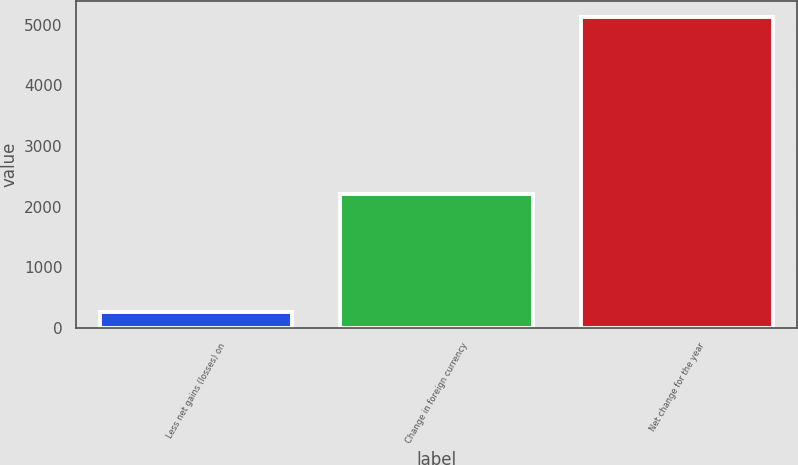Convert chart to OTSL. <chart><loc_0><loc_0><loc_500><loc_500><bar_chart><fcel>Less net gains (losses) on<fcel>Change in foreign currency<fcel>Net change for the year<nl><fcel>265<fcel>2205<fcel>5130<nl></chart> 